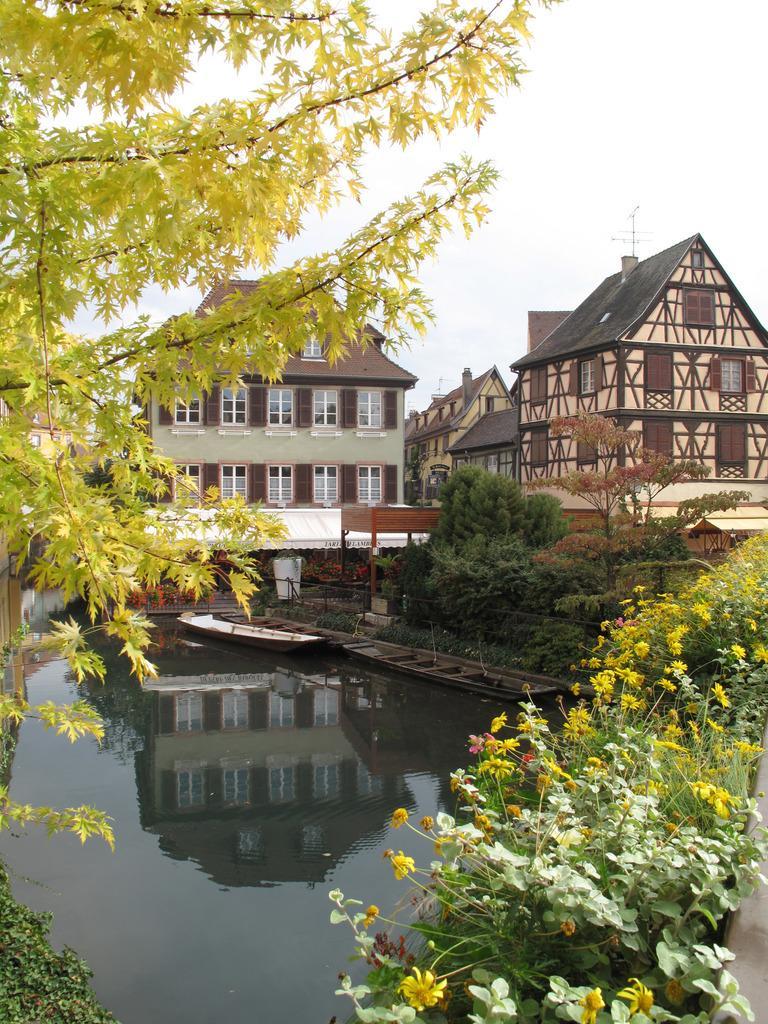Describe this image in one or two sentences. On the left side there is a tree and water. There are boats in the water. On the right side there are flowering plants. In the background there are buildings with windows. Also there are trees and sky is there in the background. 